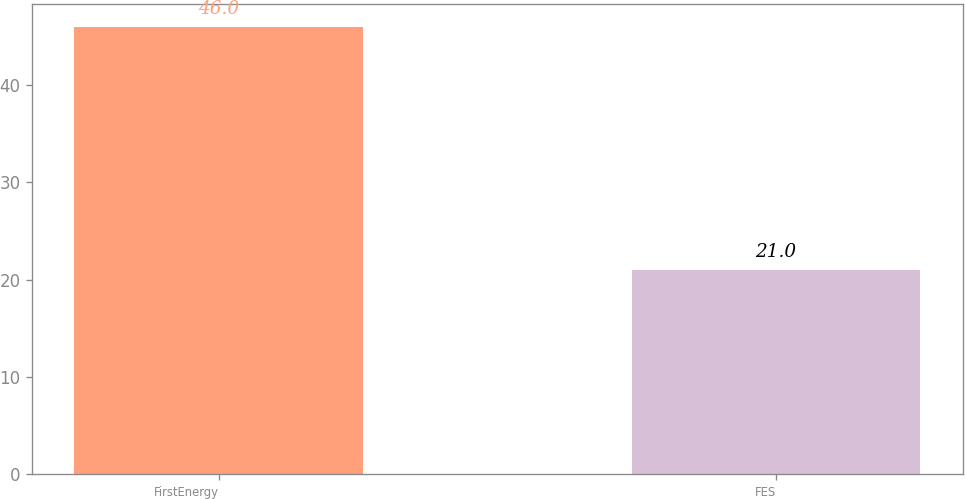Convert chart. <chart><loc_0><loc_0><loc_500><loc_500><bar_chart><fcel>FirstEnergy<fcel>FES<nl><fcel>46<fcel>21<nl></chart> 